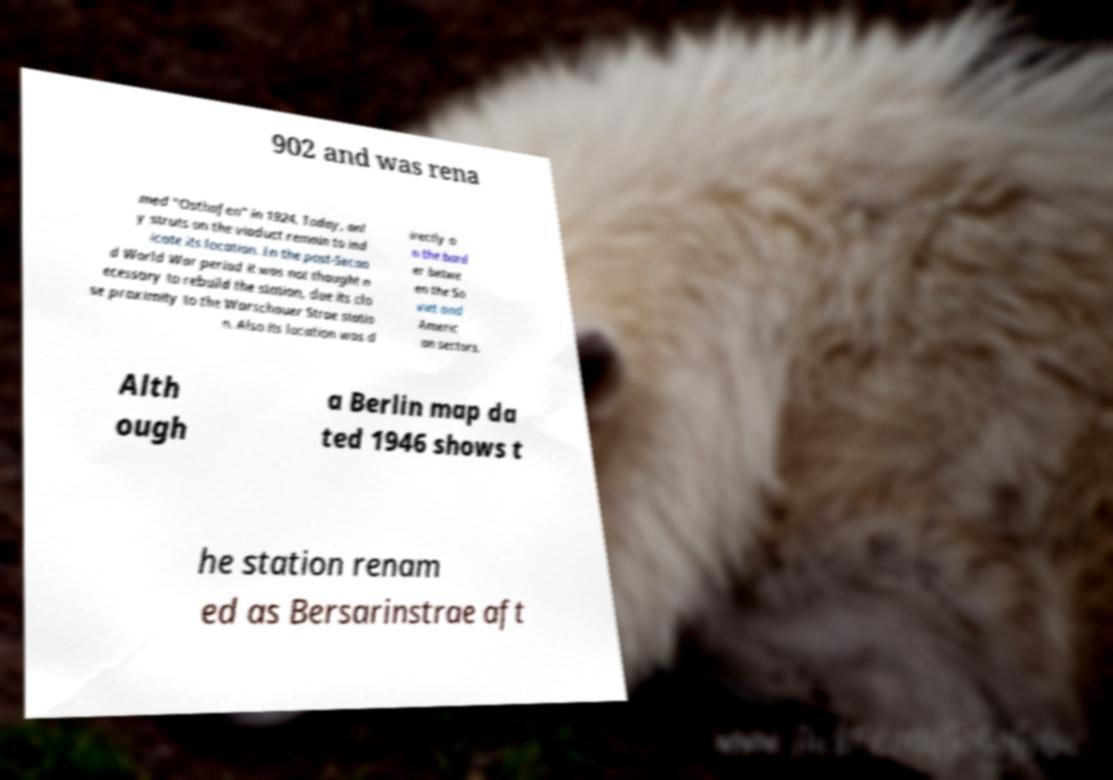Could you extract and type out the text from this image? 902 and was rena med "Osthafen" in 1924. Today, onl y struts on the viaduct remain to ind icate its location. In the post-Secon d World War period it was not thought n ecessary to rebuild the station, due its clo se proximity to the Warschauer Strae statio n. Also its location was d irectly o n the bord er betwe en the So viet and Americ an sectors. Alth ough a Berlin map da ted 1946 shows t he station renam ed as Bersarinstrae aft 